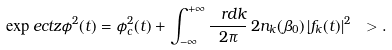<formula> <loc_0><loc_0><loc_500><loc_500>\exp e c t z { \phi ^ { 2 } ( t ) } = \phi _ { c } ^ { 2 } ( t ) + \int _ { - \infty } ^ { + \infty } \frac { \ r d k } { 2 \pi } \, 2 n _ { k } ( \beta _ { 0 } ) \, | f _ { k } ( t ) | ^ { 2 } \ > .</formula> 